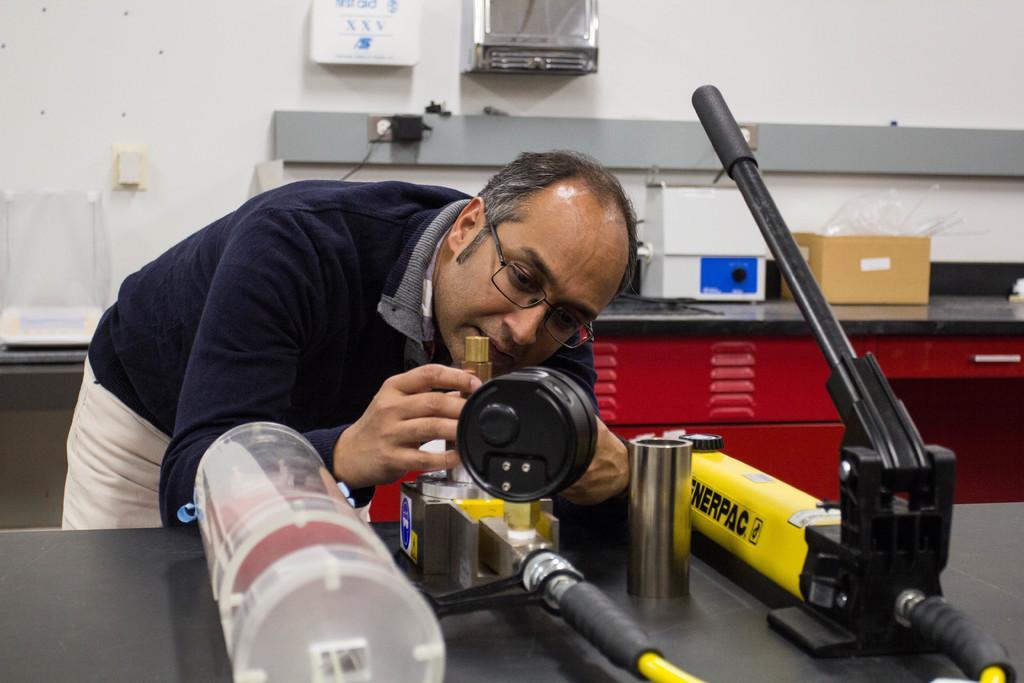How would you summarize this image in a sentence or two? In this picture there is a man standing and holding the object and there are objects on the table. At the back there is a cardboard box and there is a device on the table. There is a box and there is a board on the wall and there is a switch board on the wall. 